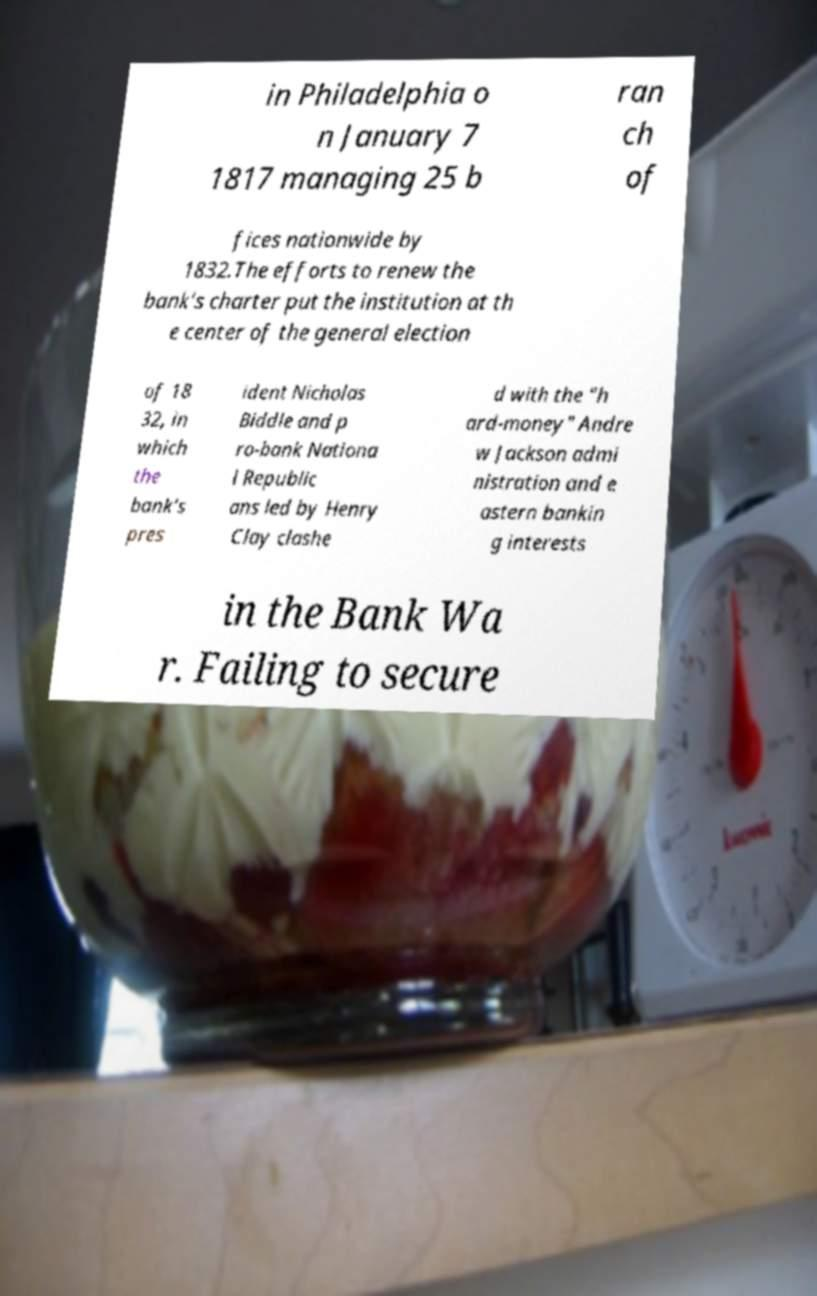Please read and relay the text visible in this image. What does it say? in Philadelphia o n January 7 1817 managing 25 b ran ch of fices nationwide by 1832.The efforts to renew the bank's charter put the institution at th e center of the general election of 18 32, in which the bank's pres ident Nicholas Biddle and p ro-bank Nationa l Republic ans led by Henry Clay clashe d with the "h ard-money" Andre w Jackson admi nistration and e astern bankin g interests in the Bank Wa r. Failing to secure 